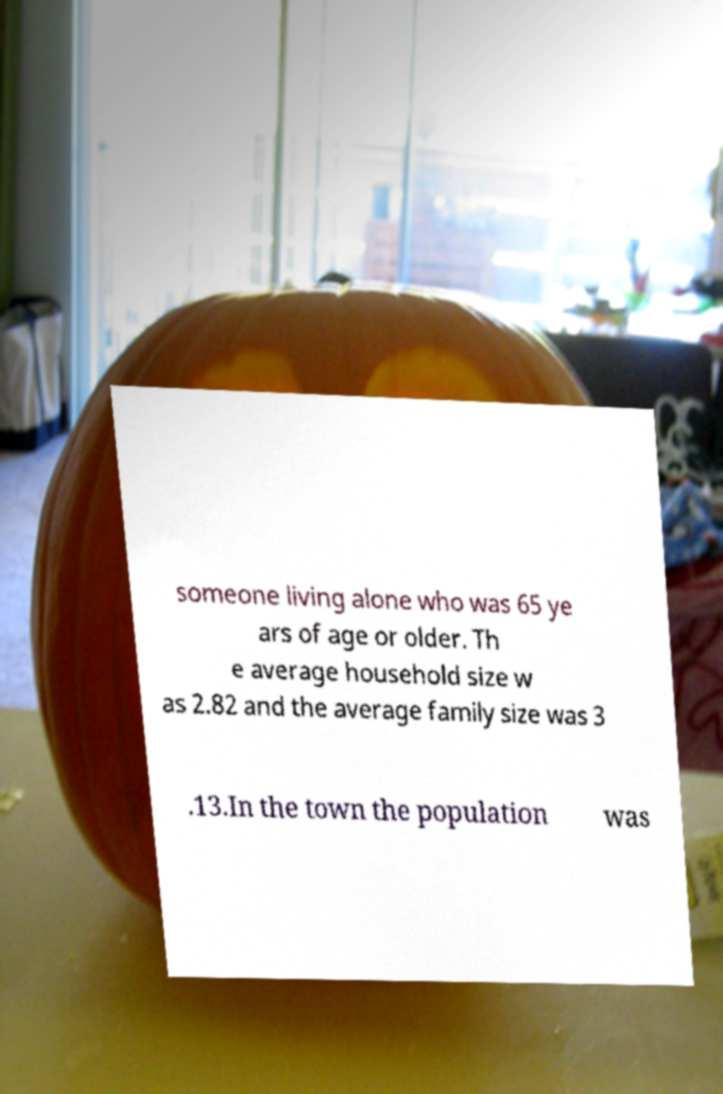What messages or text are displayed in this image? I need them in a readable, typed format. someone living alone who was 65 ye ars of age or older. Th e average household size w as 2.82 and the average family size was 3 .13.In the town the population was 